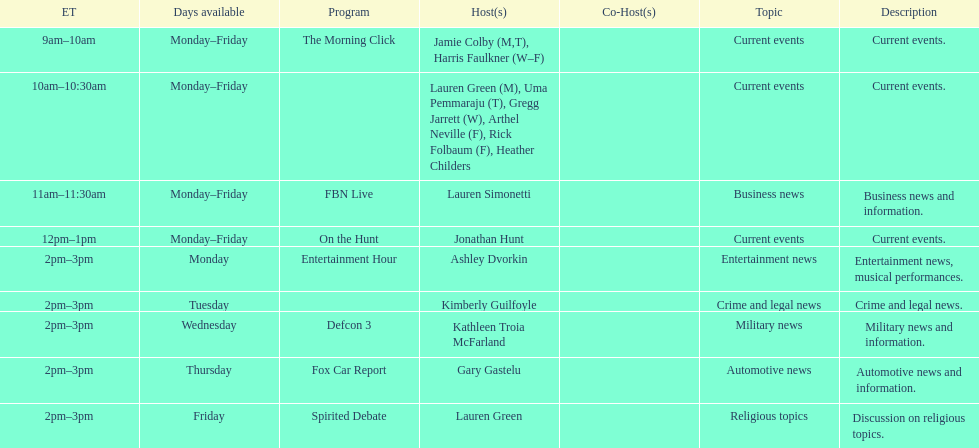How many days during the week does the show fbn live air? 5. 